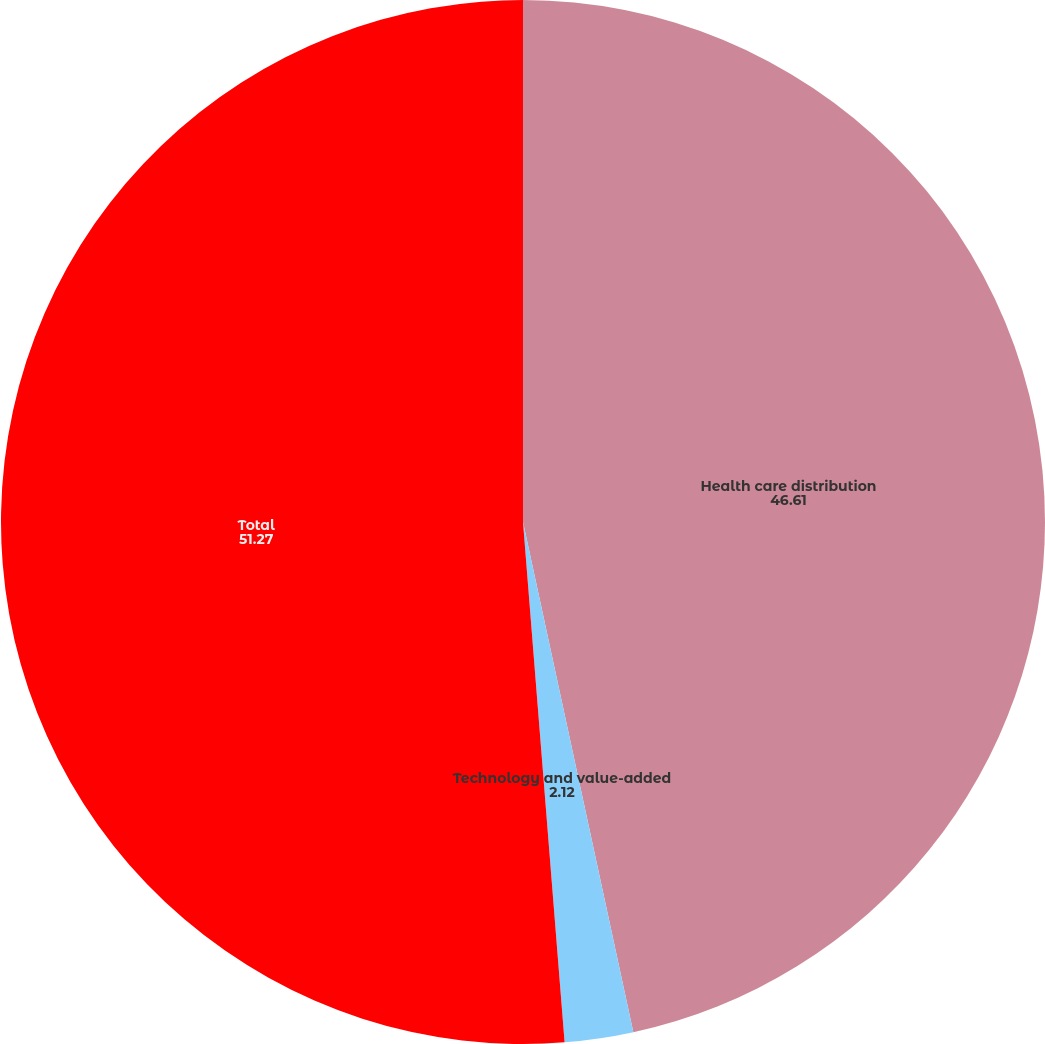Convert chart. <chart><loc_0><loc_0><loc_500><loc_500><pie_chart><fcel>Health care distribution<fcel>Technology and value-added<fcel>Total<nl><fcel>46.61%<fcel>2.12%<fcel>51.27%<nl></chart> 